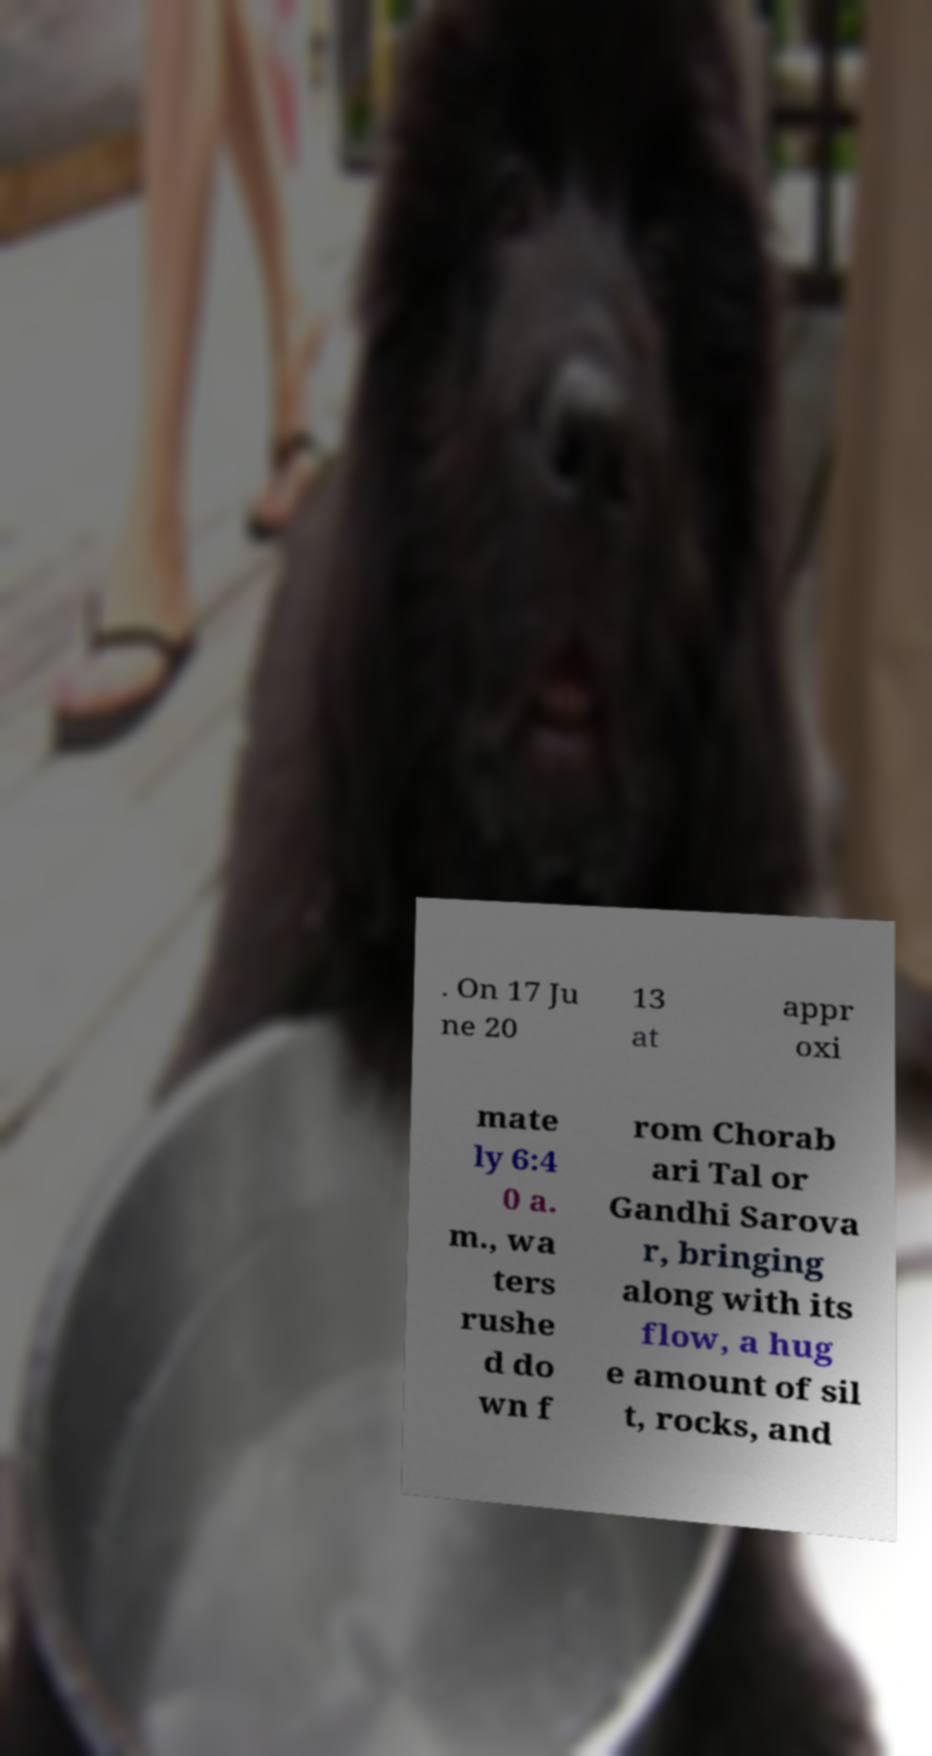For documentation purposes, I need the text within this image transcribed. Could you provide that? . On 17 Ju ne 20 13 at appr oxi mate ly 6:4 0 a. m., wa ters rushe d do wn f rom Chorab ari Tal or Gandhi Sarova r, bringing along with its flow, a hug e amount of sil t, rocks, and 